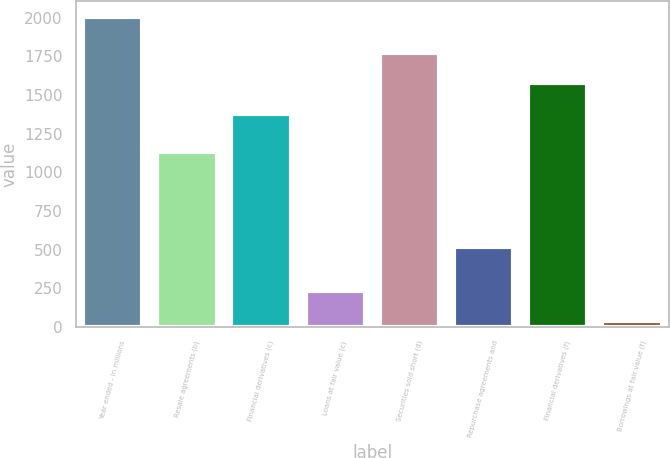<chart> <loc_0><loc_0><loc_500><loc_500><bar_chart><fcel>Year ended - in millions<fcel>Resale agreements (b)<fcel>Financial derivatives (c)<fcel>Loans at fair value (c)<fcel>Securities sold short (d)<fcel>Repurchase agreements and<fcel>Financial derivatives (f)<fcel>Borrowings at fair value (f)<nl><fcel>2007<fcel>1133<fcel>1378<fcel>235.8<fcel>1771.6<fcel>520<fcel>1574.8<fcel>39<nl></chart> 